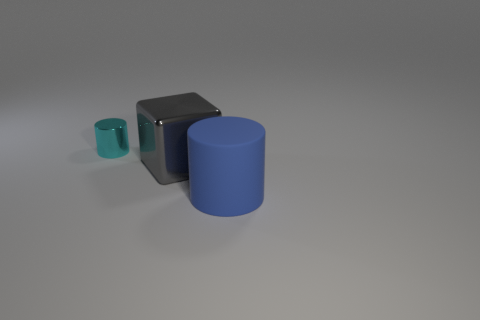The tiny cylinder has what color?
Offer a terse response. Cyan. What number of metallic objects are tiny things or big blue cylinders?
Provide a short and direct response. 1. Is there any other thing that has the same material as the big blue cylinder?
Give a very brief answer. No. What is the size of the metal thing that is right of the shiny object that is left of the metallic object to the right of the tiny cylinder?
Provide a succinct answer. Large. What size is the object that is on the right side of the tiny cyan metal cylinder and behind the blue cylinder?
Offer a terse response. Large. Does the cylinder that is behind the blue cylinder have the same color as the cylinder in front of the small metal object?
Your answer should be compact. No. How many large cylinders are on the right side of the block?
Your answer should be very brief. 1. There is a metallic thing that is in front of the cylinder that is on the left side of the blue rubber cylinder; are there any large gray metal things that are behind it?
Provide a short and direct response. No. What number of gray shiny objects are the same size as the cyan metal cylinder?
Your answer should be compact. 0. There is a cylinder on the right side of the large object that is left of the matte thing; what is its material?
Give a very brief answer. Rubber. 